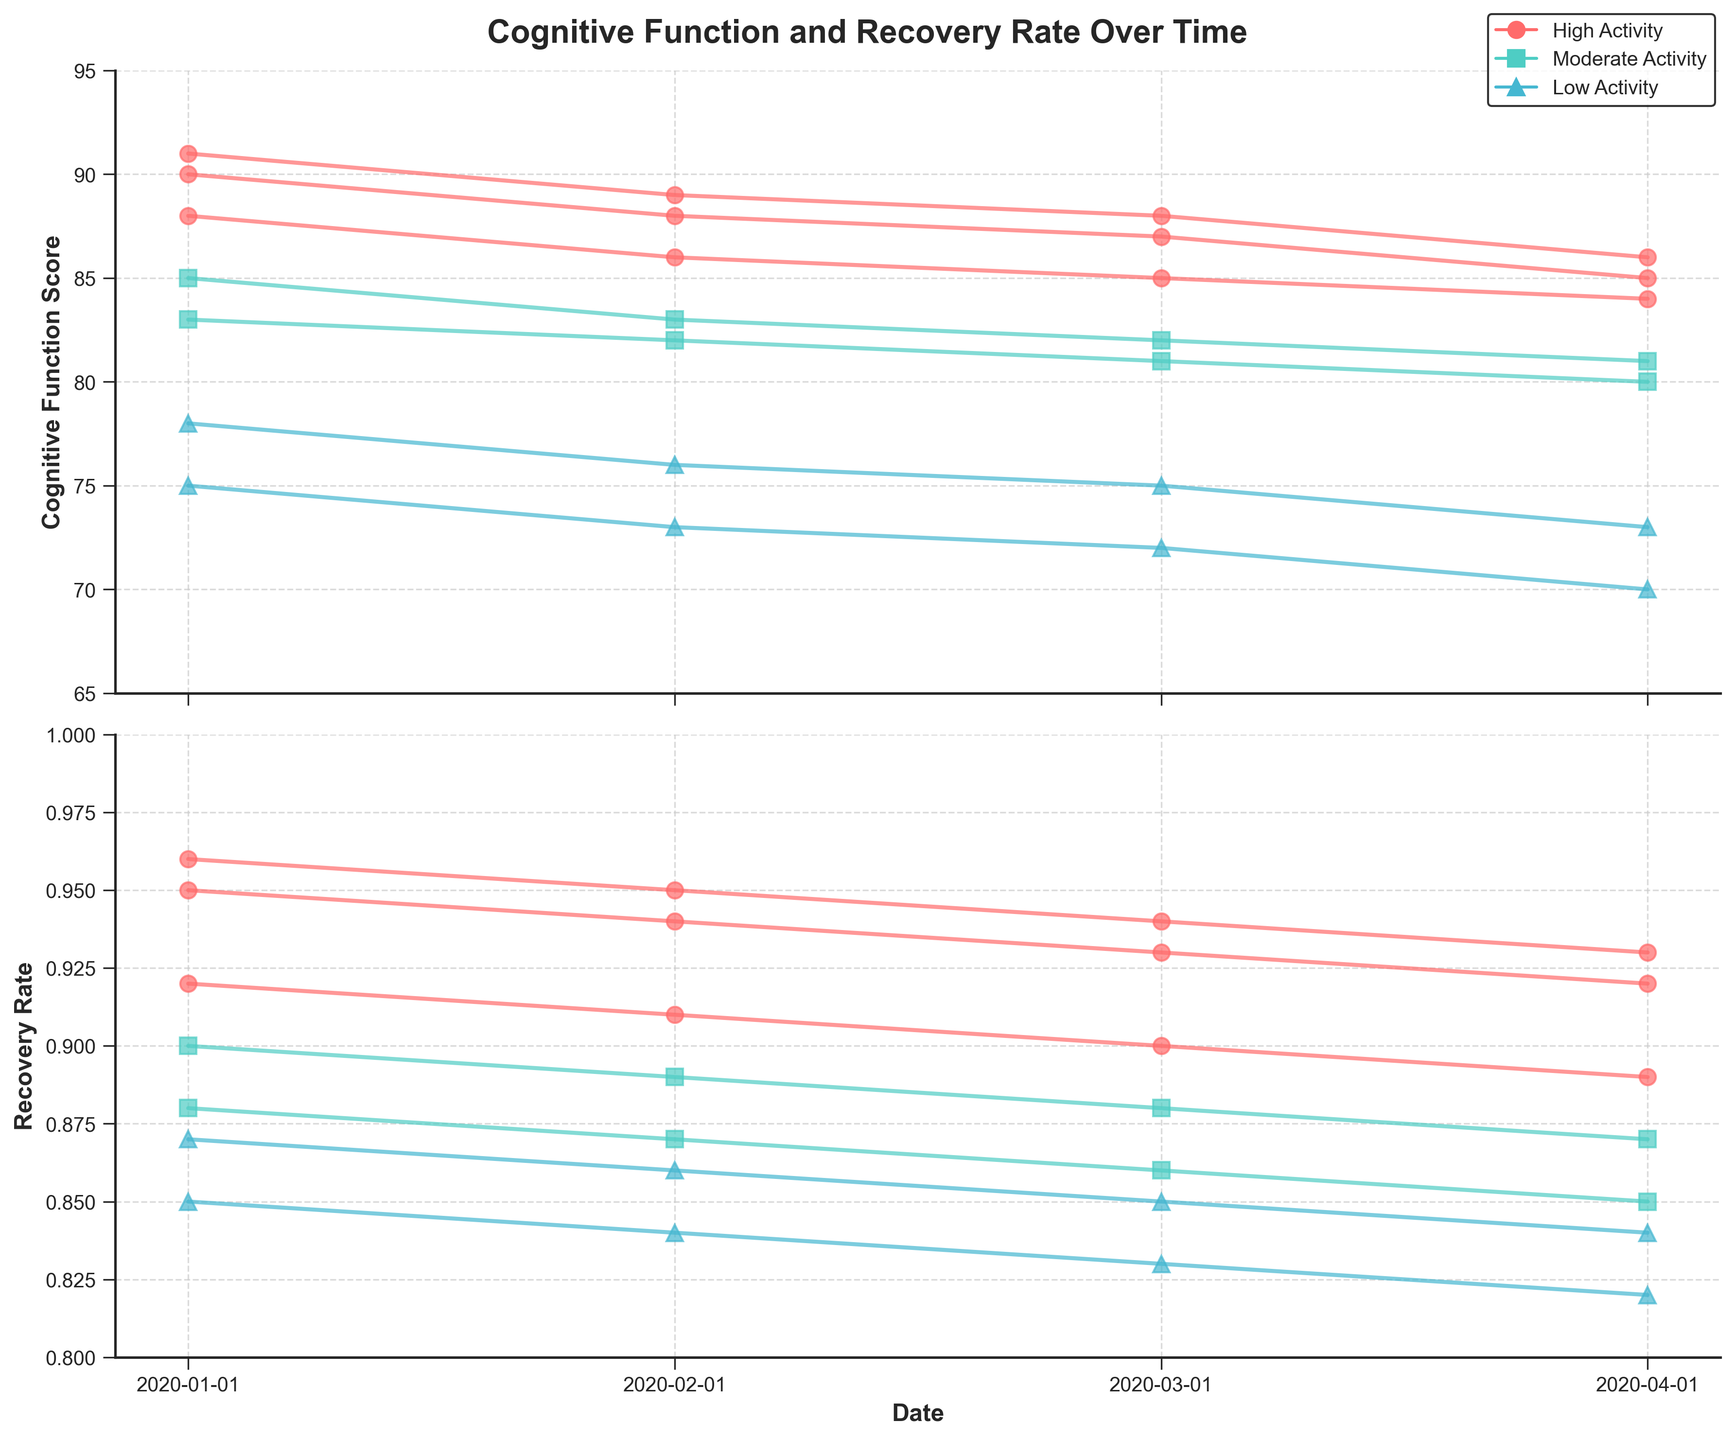What is the title of the figure? The title is located at the top of the figure.
Answer: Cognitive Function and Recovery Rate Over Time How many patients have a "Moderate" physical activity level? Look at the legend to identify the color and symbol for "Moderate" activity, then count the corresponding lines in the plot.
Answer: 2 What is the trend in cognitive function scores for patients with a high physical activity level? Identify the lines corresponding to the high physical activity level and observe their general direction over time.
Answer: Decreasing Which patient had the highest cognitive function score at the beginning of the study? Check the cognitive function scores for all patients on the initial date.
Answer: Patient 107 By how much did the cognitive function score of patient 102 (low activity level) decrease from January to April 2020? Subtract the cognitive function score of April 2020 from January 2020 for patient 102.
Answer: 5 points Which physical activity level shows the least decrease in cognitive function scores over time? Compare the slopes of the lines for different physical activity levels and find the one with the least negative slope.
Answer: Moderate What is the average recovery rate for patients with a high physical activity level in April 2020? Sum the recovery rates in April 2020 for patients with high activity levels and divide by the number of those patients.
Answer: (0.92 + 0.89 + 0.93) / 3 = 0.9133 Do higher physical activity levels correspond to higher initial cognitive function scores? Compare initial cognitive function scores across different activity levels to see if higher levels have higher scores.
Answer: Yes How does the recovery rate for patient 106 change over time? Follow the recovery rate of patient 106 across the time points and note the trend.
Answer: Decreases Which patient has shown the greatest consistency in recovery rate over the study period? Find the patient whose recovery rate changed the least over the time period.
Answer: Patient 107 